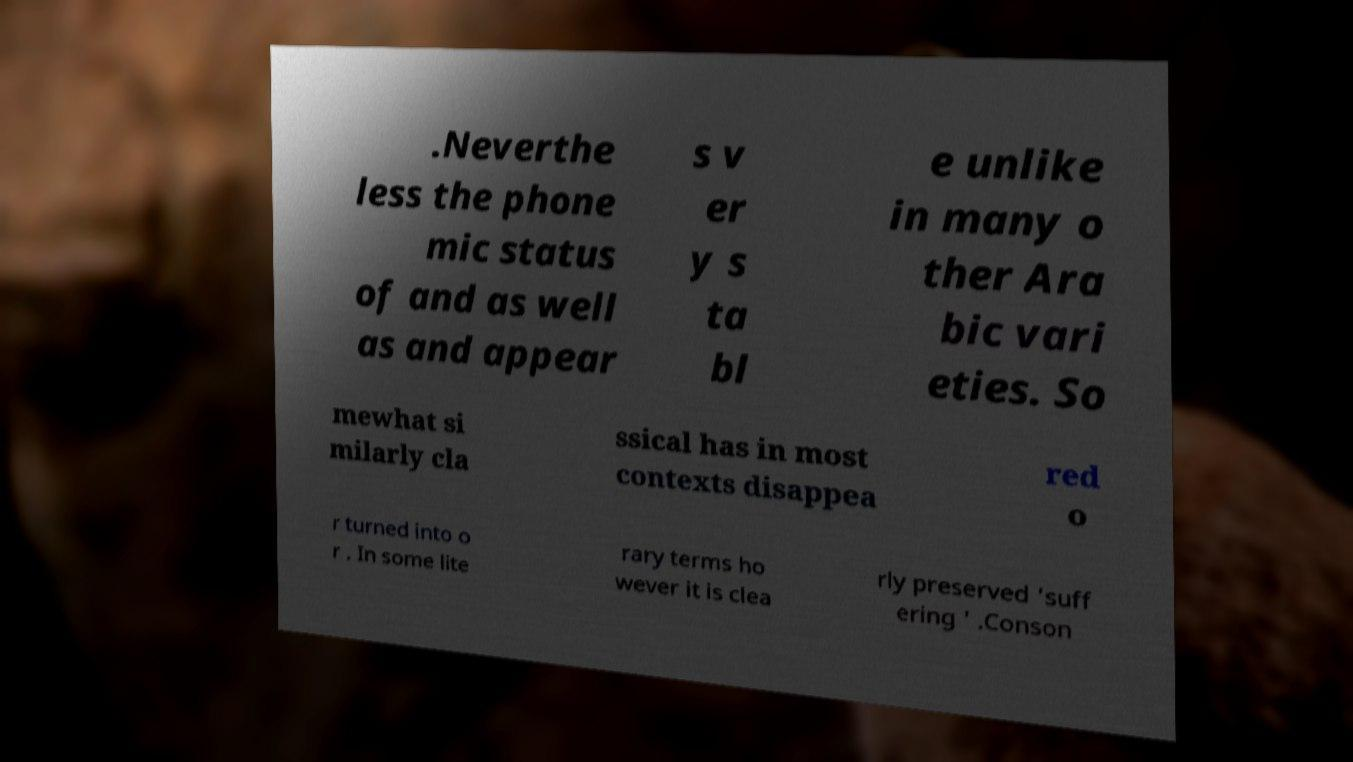Can you read and provide the text displayed in the image?This photo seems to have some interesting text. Can you extract and type it out for me? .Neverthe less the phone mic status of and as well as and appear s v er y s ta bl e unlike in many o ther Ara bic vari eties. So mewhat si milarly cla ssical has in most contexts disappea red o r turned into o r . In some lite rary terms ho wever it is clea rly preserved 'suff ering ' .Conson 